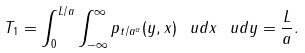Convert formula to latex. <formula><loc_0><loc_0><loc_500><loc_500>T _ { 1 } = \int _ { 0 } ^ { L / a } \int _ { - \infty } ^ { \infty } p _ { t / a ^ { \alpha } } ( y , x ) \, \ u d x \, \ u d y = \frac { L } { a } .</formula> 